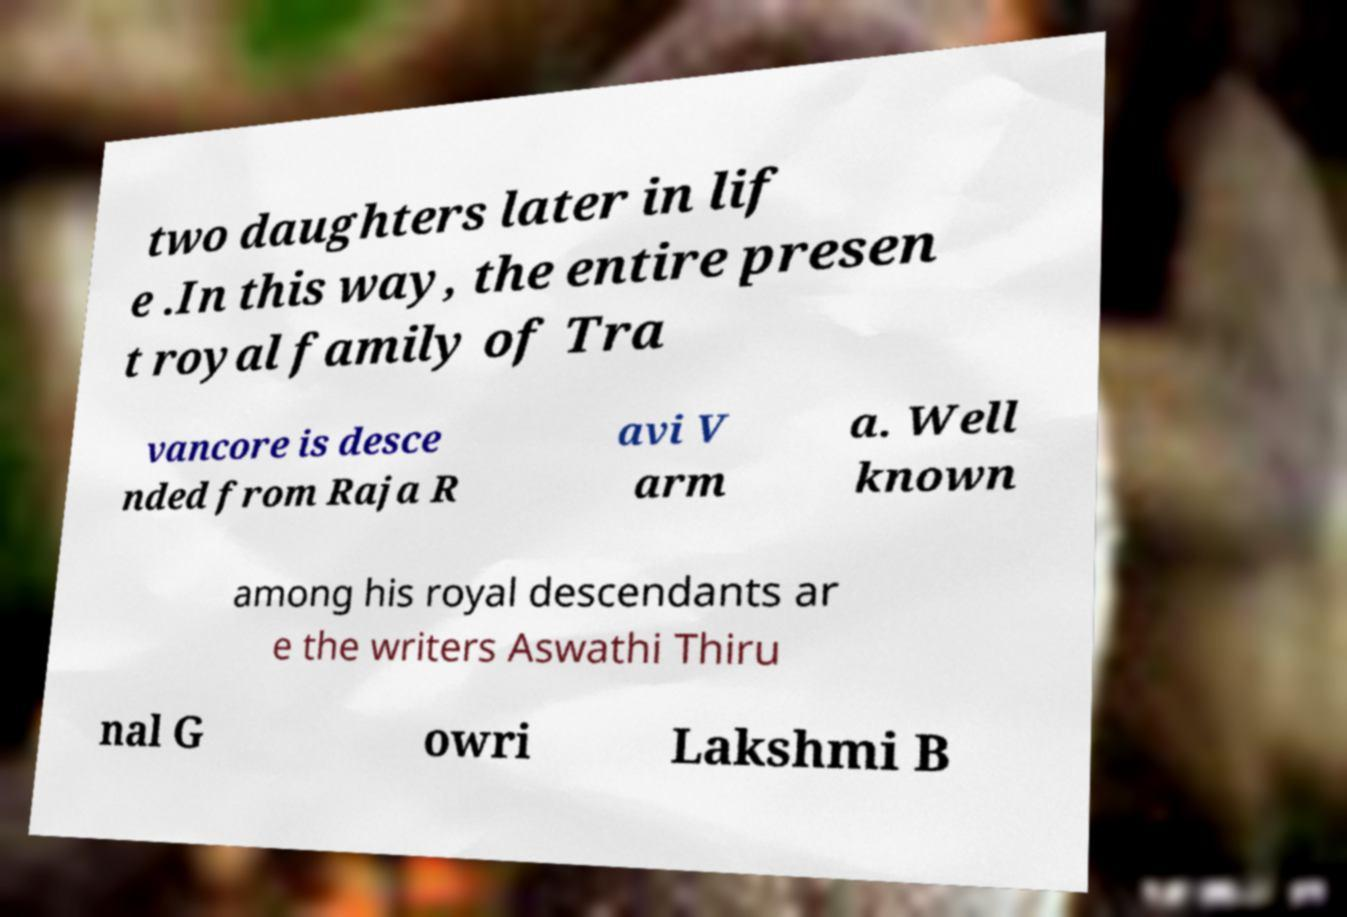Could you assist in decoding the text presented in this image and type it out clearly? two daughters later in lif e .In this way, the entire presen t royal family of Tra vancore is desce nded from Raja R avi V arm a. Well known among his royal descendants ar e the writers Aswathi Thiru nal G owri Lakshmi B 